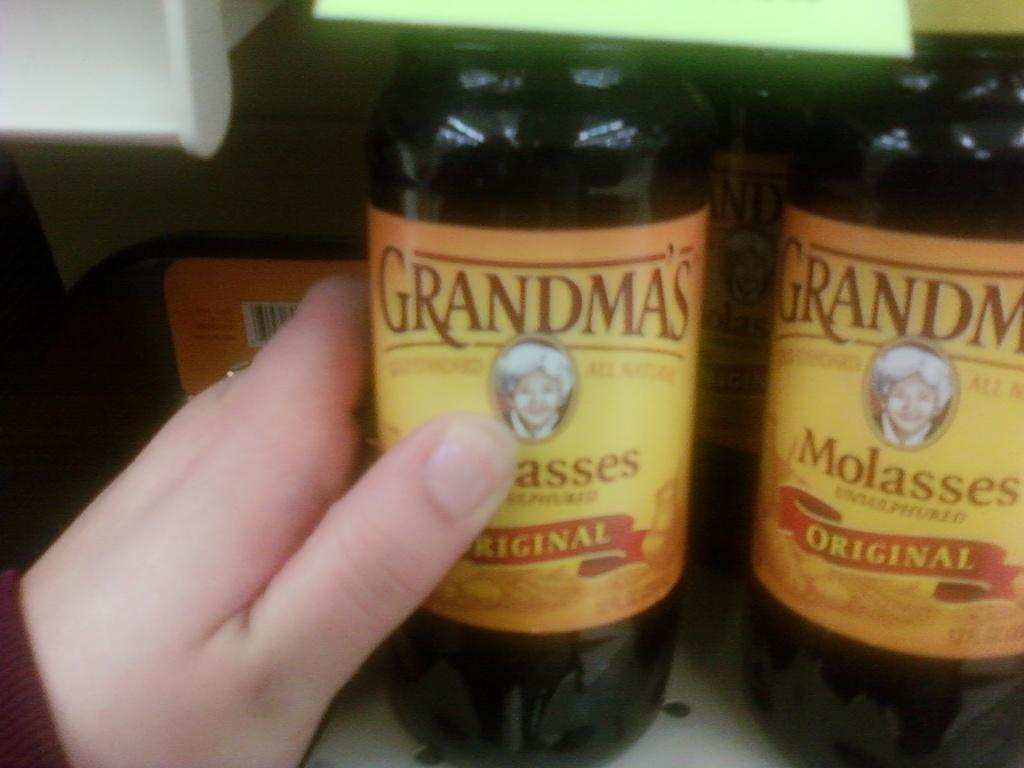<image>
Provide a brief description of the given image. A hand reaches for Grandma's molasses sitting on a shelf. 